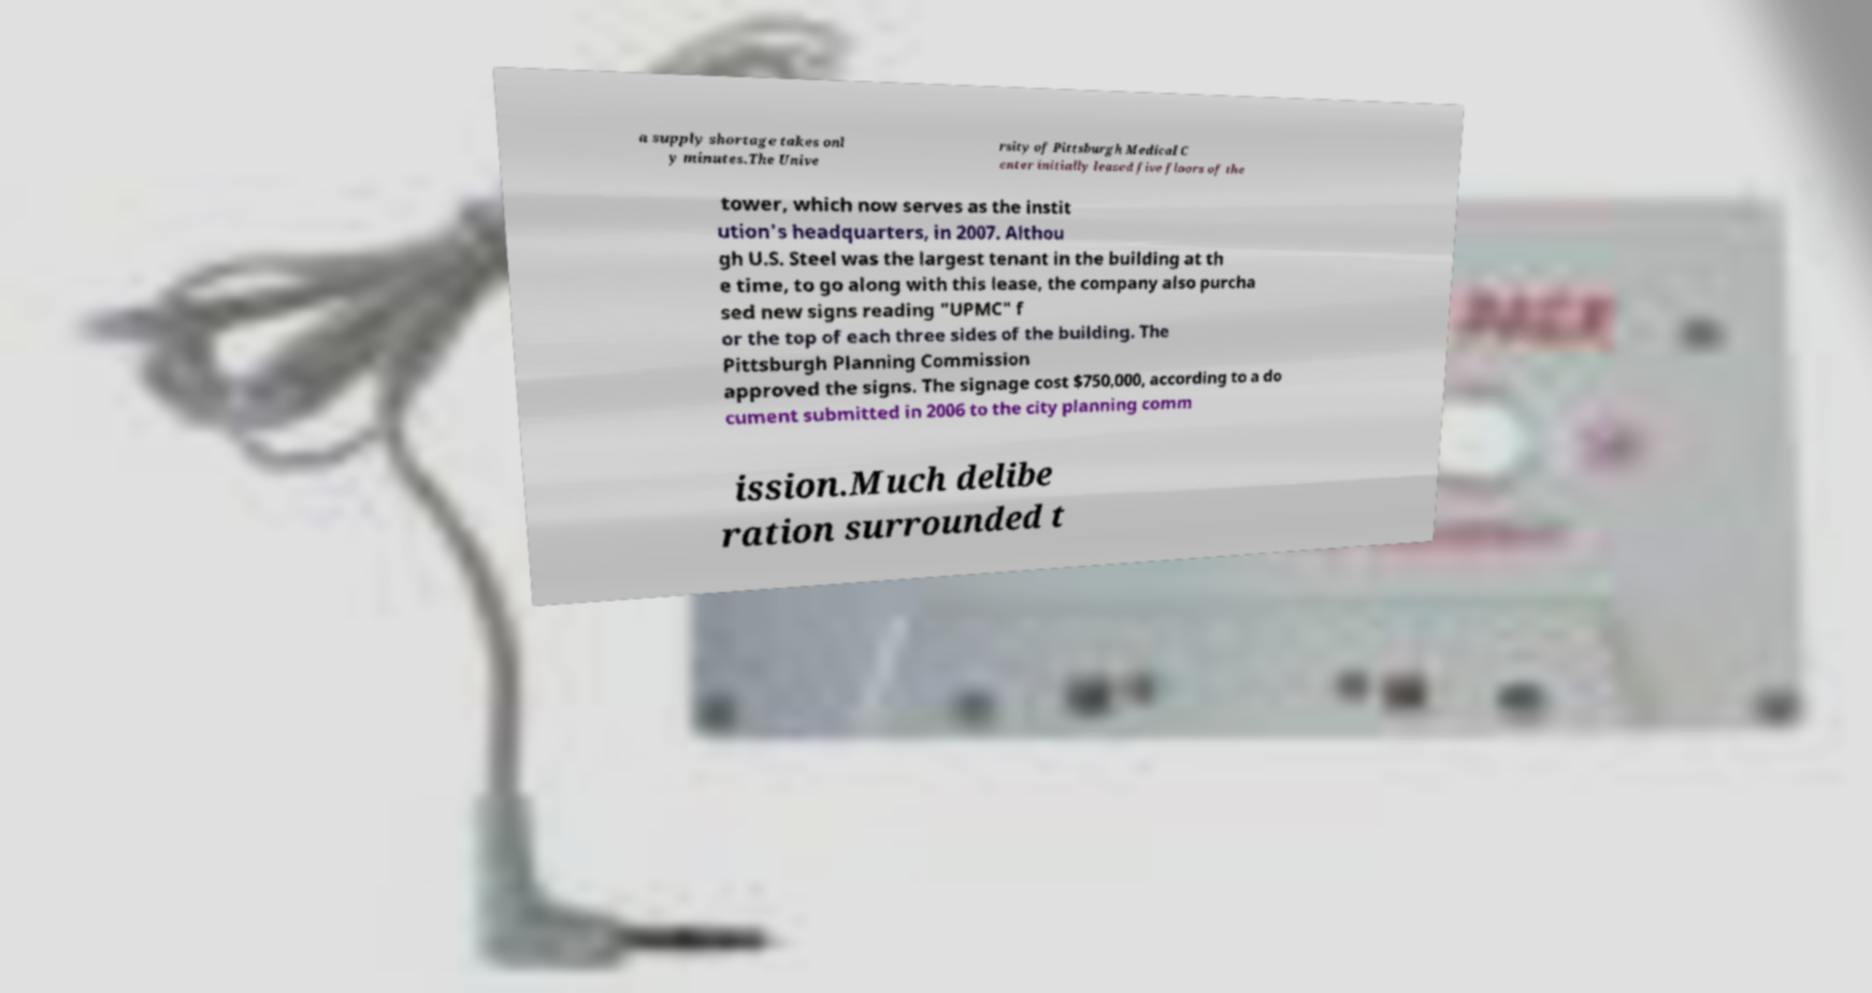Please identify and transcribe the text found in this image. a supply shortage takes onl y minutes.The Unive rsity of Pittsburgh Medical C enter initially leased five floors of the tower, which now serves as the instit ution's headquarters, in 2007. Althou gh U.S. Steel was the largest tenant in the building at th e time, to go along with this lease, the company also purcha sed new signs reading "UPMC" f or the top of each three sides of the building. The Pittsburgh Planning Commission approved the signs. The signage cost $750,000, according to a do cument submitted in 2006 to the city planning comm ission.Much delibe ration surrounded t 